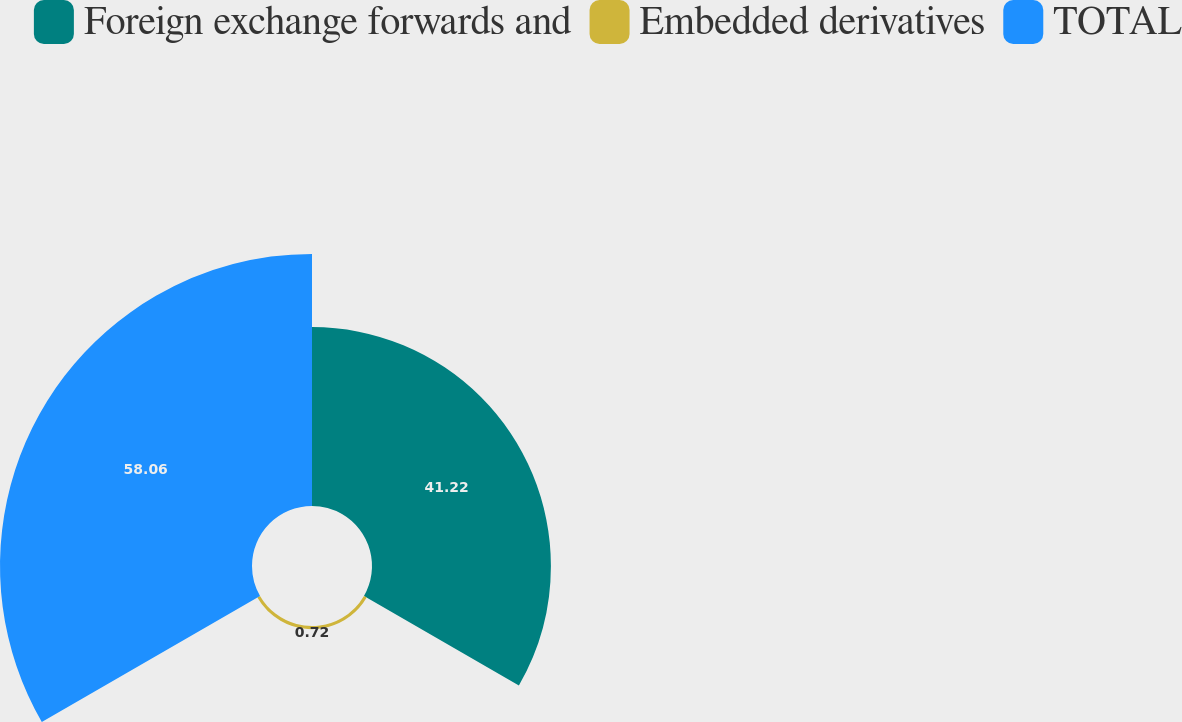Convert chart. <chart><loc_0><loc_0><loc_500><loc_500><pie_chart><fcel>Foreign exchange forwards and<fcel>Embedded derivatives<fcel>TOTAL<nl><fcel>41.22%<fcel>0.72%<fcel>58.06%<nl></chart> 